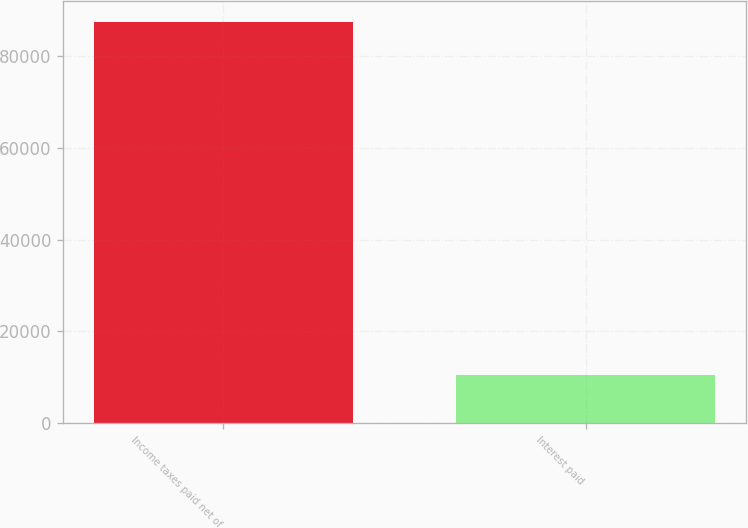Convert chart. <chart><loc_0><loc_0><loc_500><loc_500><bar_chart><fcel>Income taxes paid net of<fcel>Interest paid<nl><fcel>87591<fcel>10425<nl></chart> 